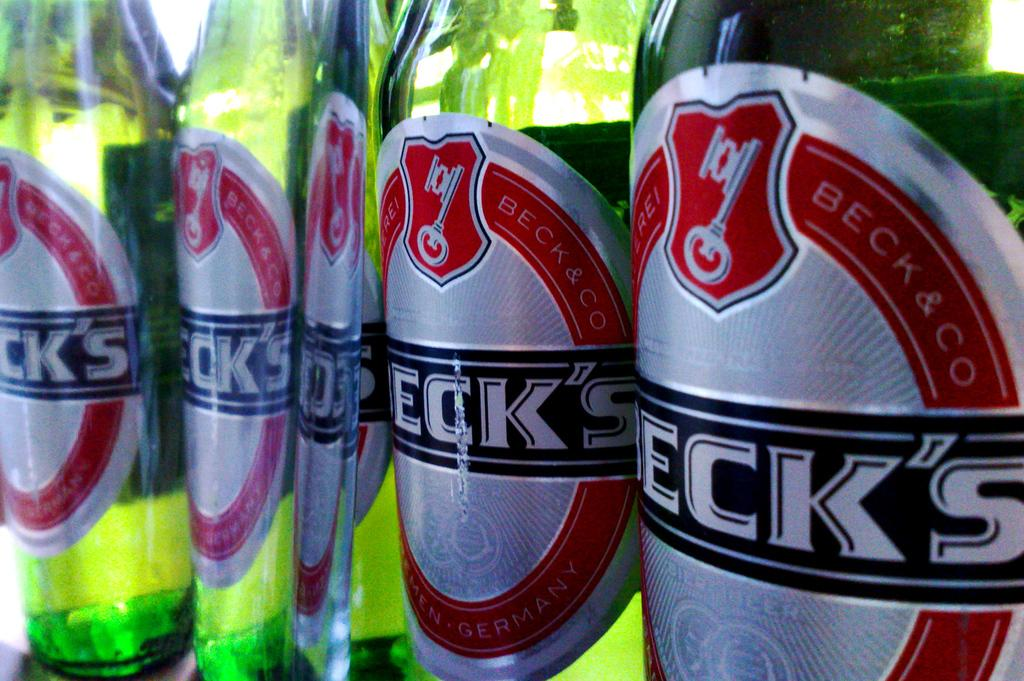<image>
Summarize the visual content of the image. close up of several Beck's beer bottle labels 